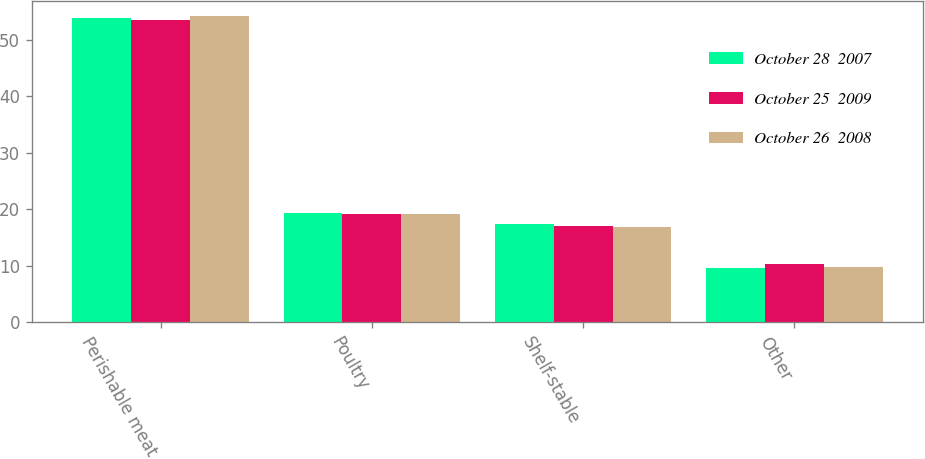<chart> <loc_0><loc_0><loc_500><loc_500><stacked_bar_chart><ecel><fcel>Perishable meat<fcel>Poultry<fcel>Shelf-stable<fcel>Other<nl><fcel>October 28  2007<fcel>53.9<fcel>19.3<fcel>17.3<fcel>9.5<nl><fcel>October 25  2009<fcel>53.5<fcel>19.2<fcel>17.1<fcel>10.2<nl><fcel>October 26  2008<fcel>54.2<fcel>19.2<fcel>16.8<fcel>9.8<nl></chart> 